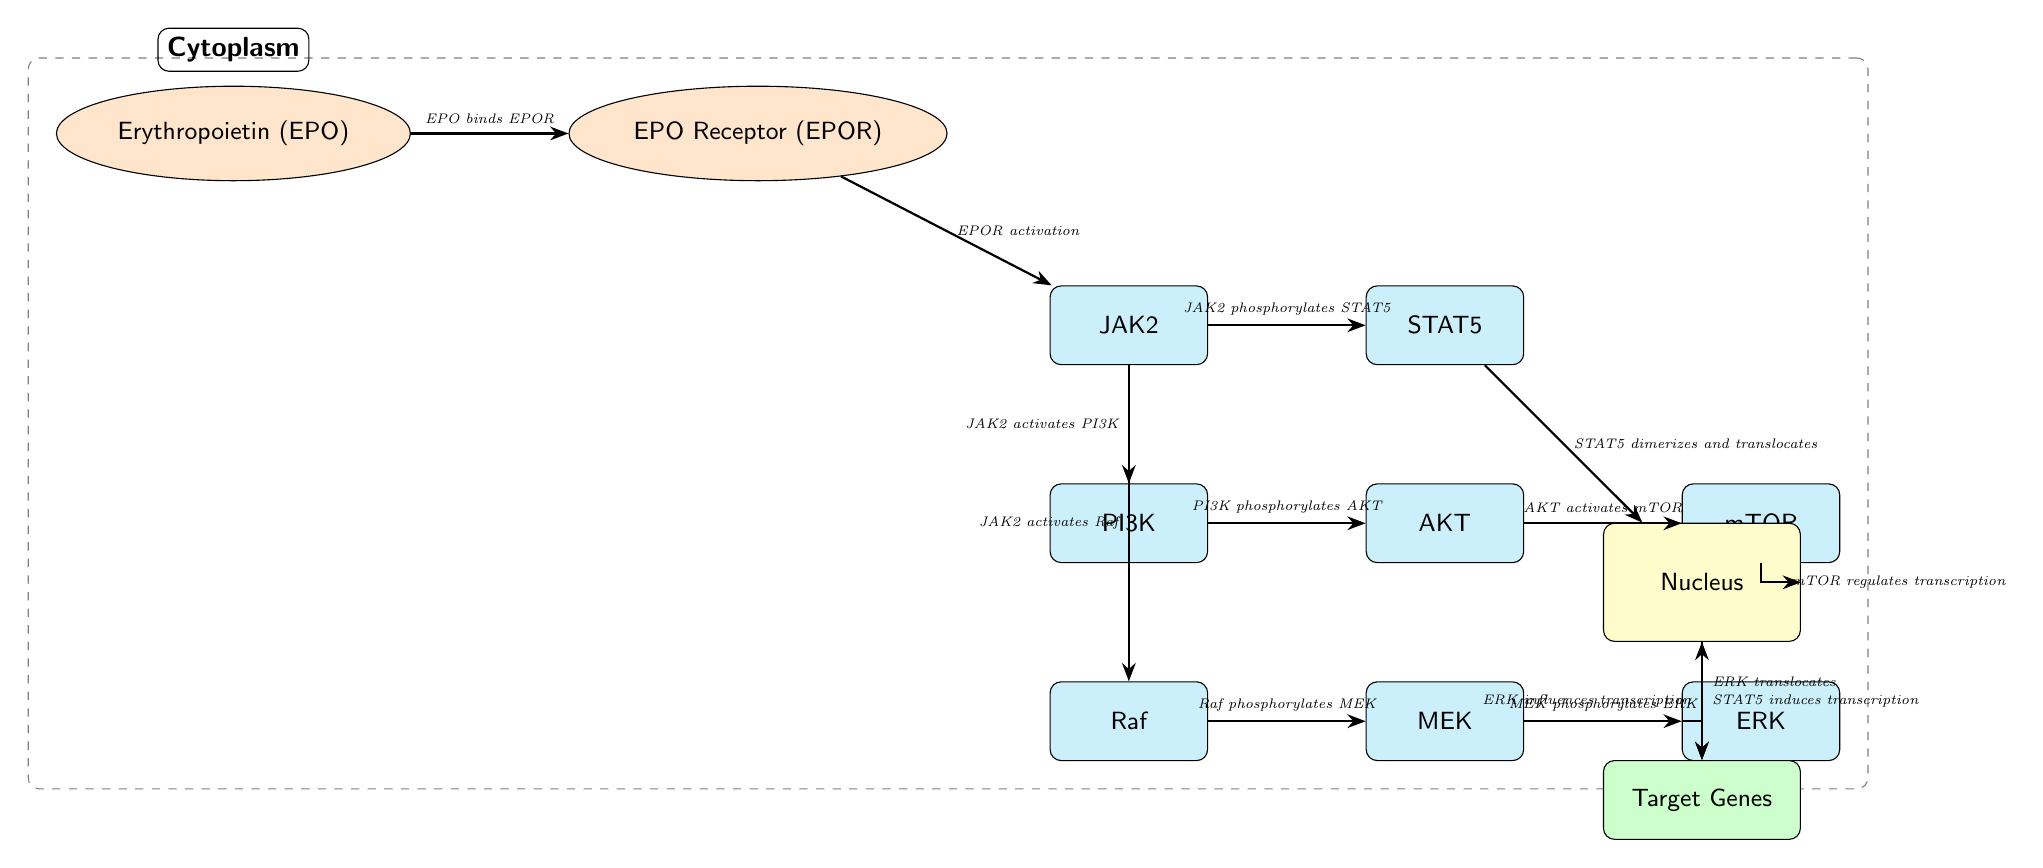What is the first node in the diagram? The first node is erythropoietin (EPO), which initiates the signaling cascade by binding to its receptor.
Answer: Erythropoietin (EPO) How many proteins are depicted in the diagram? The diagram shows six proteins: JAK2, STAT5, PI3K, AKT, mTOR, Raf, MEK, and ERK. So, there are a total of eight proteins.
Answer: Eight What does JAK2 phosphorylate? JAK2 phosphorylates STAT5 as part of the signaling pathway that leads to gene transcription in response to EPO stimulation.
Answer: STAT5 Which protein is responsible for translocating to the nucleus? STAT5 dimerizes and translocates to the nucleus, where it can induce transcription of target genes.
Answer: STAT5 What regulates transcription apart from STAT5 in the nucleus? In addition to STAT5, mTOR and ERK influence gene transcription in the nucleus as indicated by their pathways and connections to the nucleus.
Answer: mTOR and ERK Describe the pathway that leads from JAK2 to ERK. JAK2 activates Raf, which phosphorylates MEK, then MEK phosphorylates ERK, which ultimately translocates to the nucleus.
Answer: JAK2, Raf, MEK, ERK Which node represents the transcription factor that interacts directly with DNA? The node labeled as "Genes" represents the target genes where transcription occurs, influenced by transcription factors like STAT5 and ERK.
Answer: Genes What type of feedback can occur in this signaling pathway? The diagram does not explicitly depict feedback loops; however, signaling pathways can be feedback-regulated through various mechanisms such as inhibitory or stimulatory signals from products of the target genes.
Answer: Not explicitly shown 